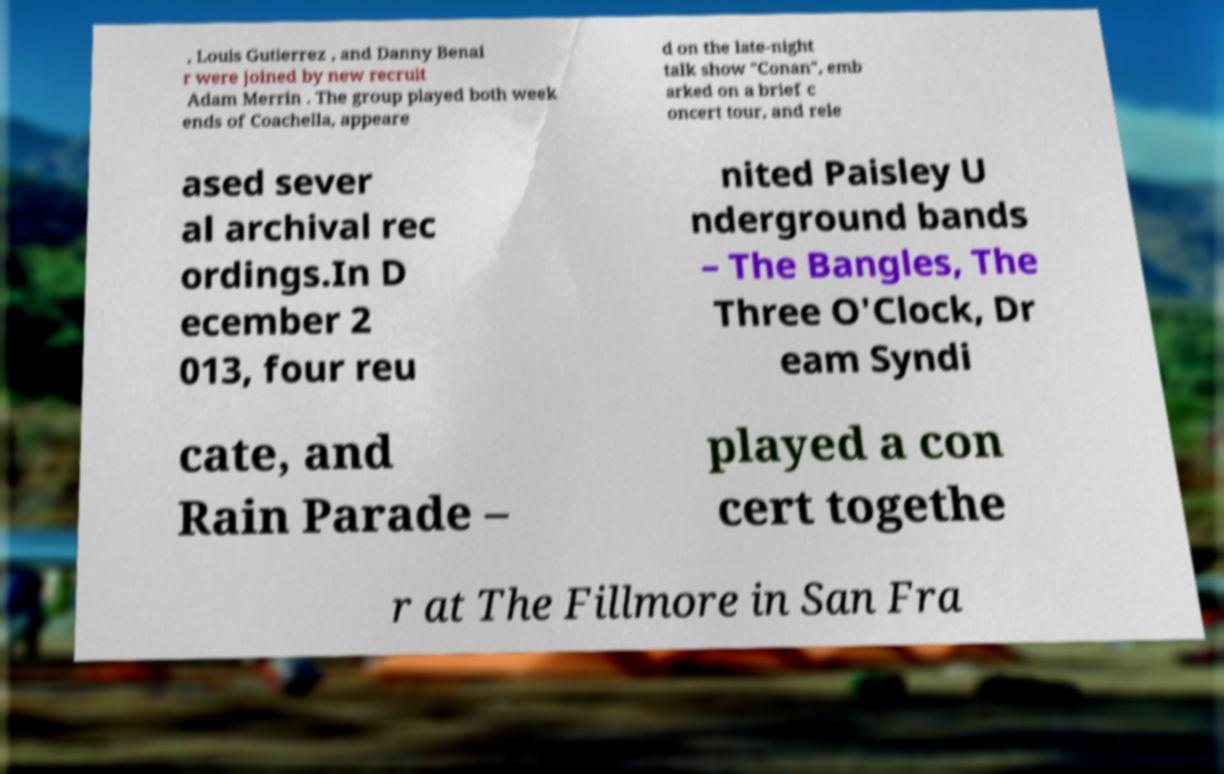For documentation purposes, I need the text within this image transcribed. Could you provide that? , Louis Gutierrez , and Danny Benai r were joined by new recruit Adam Merrin . The group played both week ends of Coachella, appeare d on the late-night talk show "Conan", emb arked on a brief c oncert tour, and rele ased sever al archival rec ordings.In D ecember 2 013, four reu nited Paisley U nderground bands – The Bangles, The Three O'Clock, Dr eam Syndi cate, and Rain Parade – played a con cert togethe r at The Fillmore in San Fra 